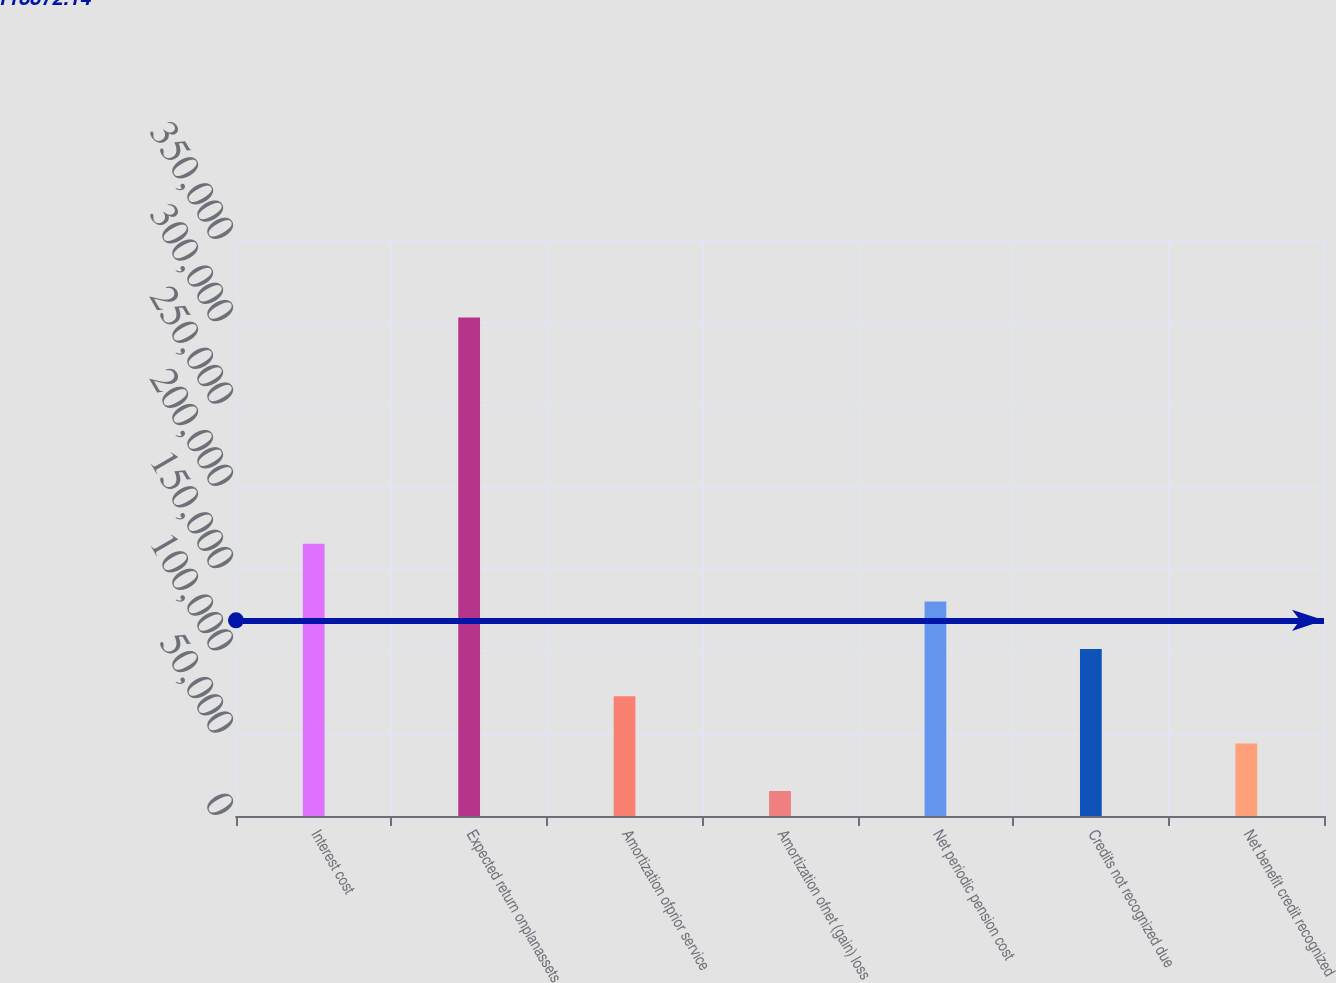<chart> <loc_0><loc_0><loc_500><loc_500><bar_chart><fcel>Interest cost<fcel>Expected return onplanassets<fcel>Amortization ofprior service<fcel>Amortization ofnet (gain) loss<fcel>Net periodic pension cost<fcel>Credits not recognized due<fcel>Net benefit credit recognized<nl><fcel>165361<fcel>302958<fcel>72757.2<fcel>15207<fcel>130307<fcel>101532<fcel>43982.1<nl></chart> 